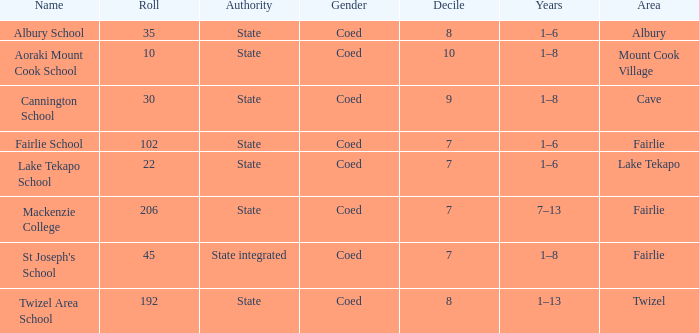What is the total Decile that has a state authority, fairlie area and roll smarter than 206? 1.0. Parse the table in full. {'header': ['Name', 'Roll', 'Authority', 'Gender', 'Decile', 'Years', 'Area'], 'rows': [['Albury School', '35', 'State', 'Coed', '8', '1–6', 'Albury'], ['Aoraki Mount Cook School', '10', 'State', 'Coed', '10', '1–8', 'Mount Cook Village'], ['Cannington School', '30', 'State', 'Coed', '9', '1–8', 'Cave'], ['Fairlie School', '102', 'State', 'Coed', '7', '1–6', 'Fairlie'], ['Lake Tekapo School', '22', 'State', 'Coed', '7', '1–6', 'Lake Tekapo'], ['Mackenzie College', '206', 'State', 'Coed', '7', '7–13', 'Fairlie'], ["St Joseph's School", '45', 'State integrated', 'Coed', '7', '1–8', 'Fairlie'], ['Twizel Area School', '192', 'State', 'Coed', '8', '1–13', 'Twizel']]} 